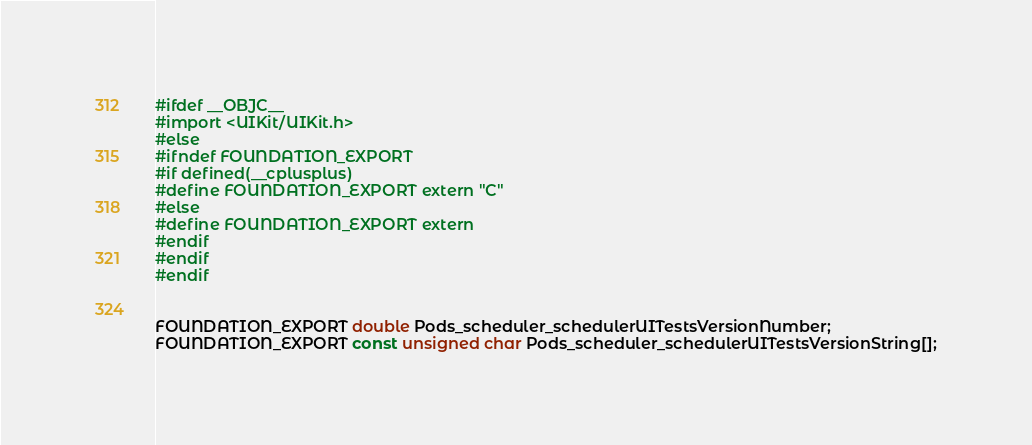Convert code to text. <code><loc_0><loc_0><loc_500><loc_500><_C_>#ifdef __OBJC__
#import <UIKit/UIKit.h>
#else
#ifndef FOUNDATION_EXPORT
#if defined(__cplusplus)
#define FOUNDATION_EXPORT extern "C"
#else
#define FOUNDATION_EXPORT extern
#endif
#endif
#endif


FOUNDATION_EXPORT double Pods_scheduler_schedulerUITestsVersionNumber;
FOUNDATION_EXPORT const unsigned char Pods_scheduler_schedulerUITestsVersionString[];

</code> 